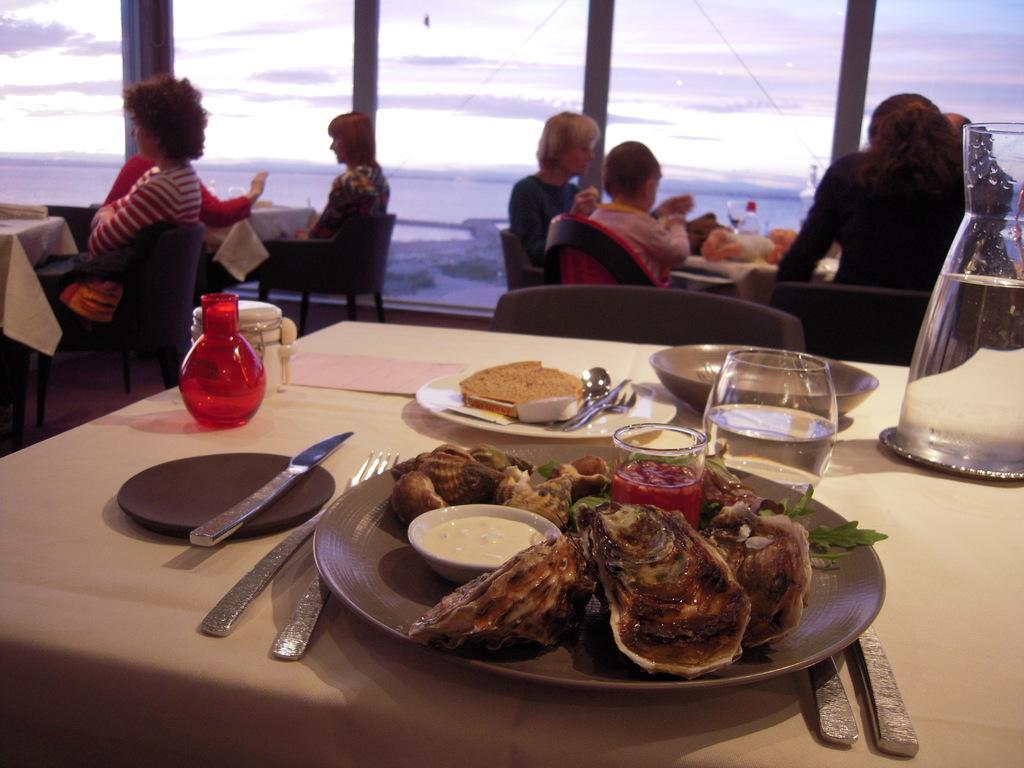Could you give a brief overview of what you see in this image? In this picture there are group of people sitting on the chairs. There is food on the plates. There are plates, glasses and there is a jar and bowl and there are forks and spoons on the table and the tables are covered with white color cloth. At the back there is a glass wall. behind the glass wall there are trees and there is water. At top there is sky and there are clouds. At the bottom there is a floor. 